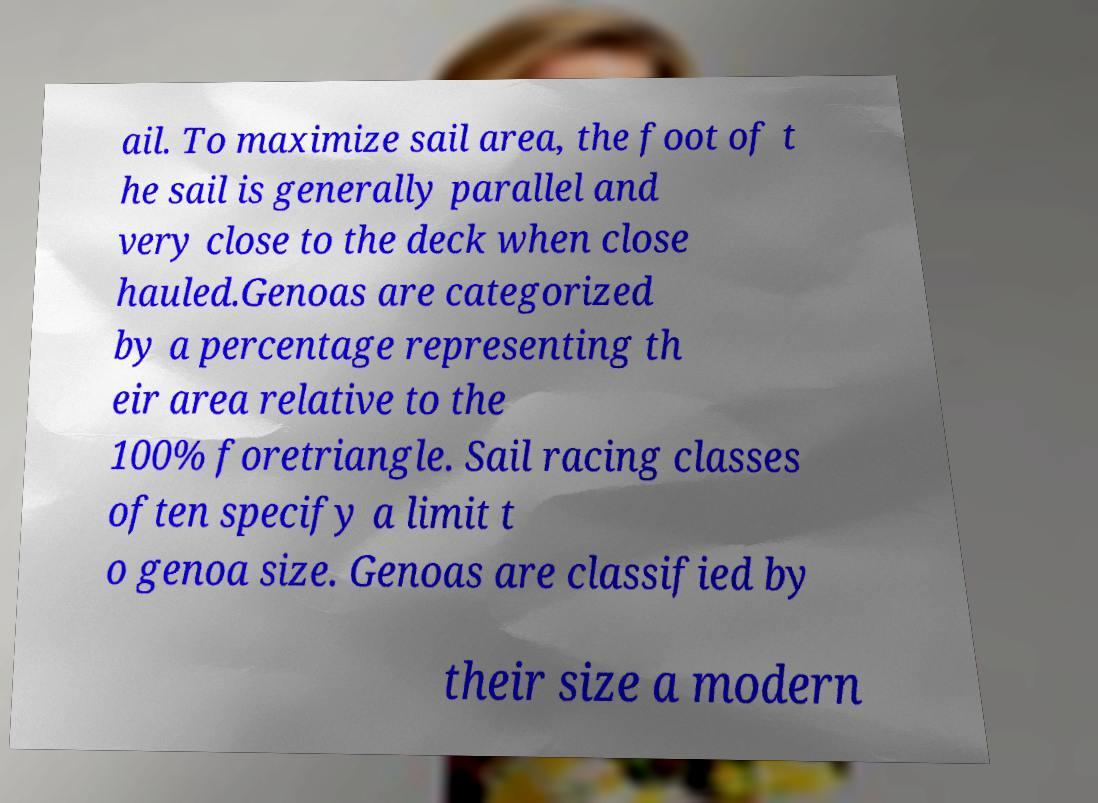Could you assist in decoding the text presented in this image and type it out clearly? ail. To maximize sail area, the foot of t he sail is generally parallel and very close to the deck when close hauled.Genoas are categorized by a percentage representing th eir area relative to the 100% foretriangle. Sail racing classes often specify a limit t o genoa size. Genoas are classified by their size a modern 